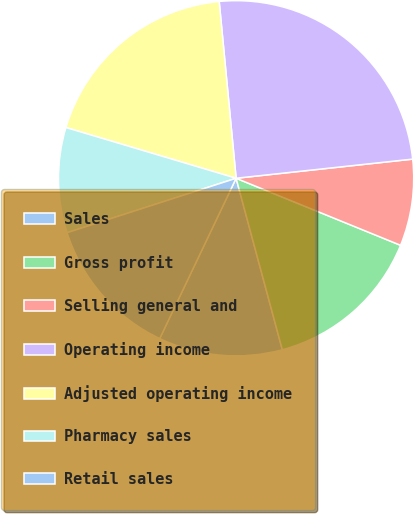<chart> <loc_0><loc_0><loc_500><loc_500><pie_chart><fcel>Sales<fcel>Gross profit<fcel>Selling general and<fcel>Operating income<fcel>Adjusted operating income<fcel>Pharmacy sales<fcel>Retail sales<nl><fcel>11.27%<fcel>14.65%<fcel>7.88%<fcel>24.8%<fcel>18.87%<fcel>9.57%<fcel>12.96%<nl></chart> 